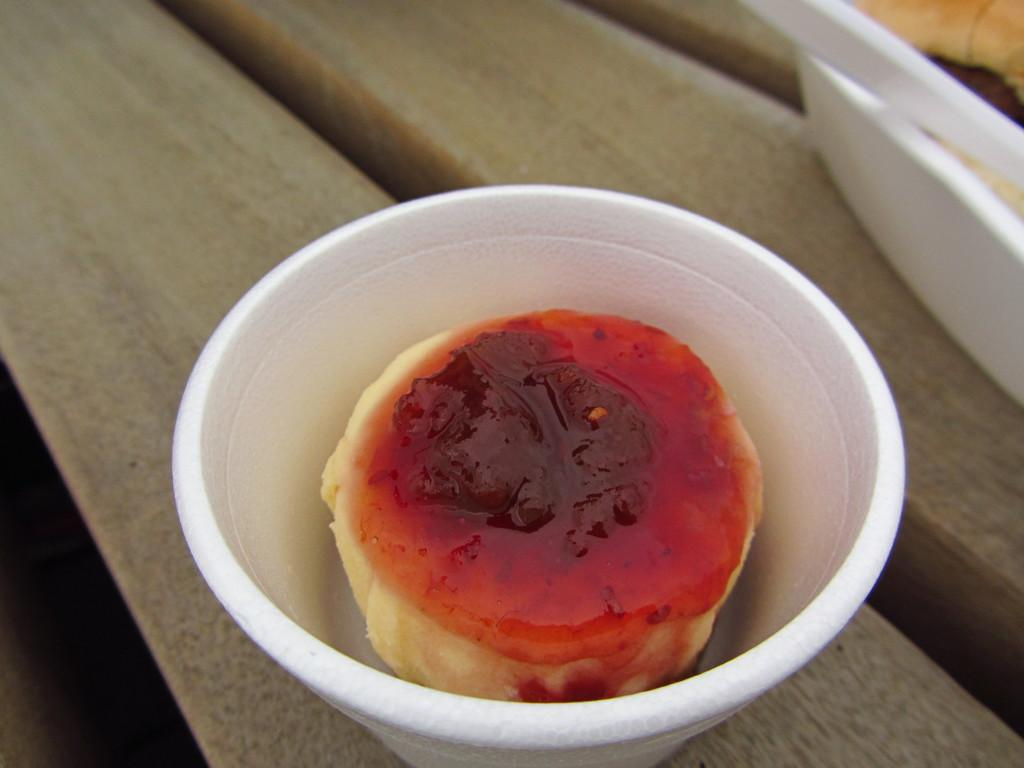What piece of furniture is present in the image? There is a table in the image. What is on the table in the image? There is a bowl containing dessert on the table. Can you describe the other bowl in the image? There is a bowl containing food in the top right corner of the image. What is the purpose of the bridge in the image? There is no bridge present in the image. 